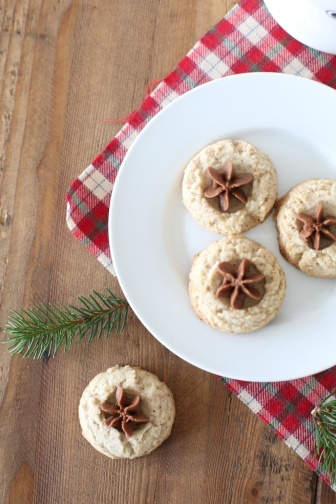What practical occasion could these cookies be prepared for? These cookies would be perfect for a family holiday gathering, a festive party with friends, or as a thoughtful homemade gift during the Christmas season. Their elegant and festive decoration makes them ideal for any occasion celebrating warmth, togetherness, and the holiday spirit. Imagine a playful interaction involving these cookies at a family holiday gathering. During the family holiday gathering, Uncle Tim, with a twinkle in his eye, announced a cookie decorating contest. Each family member would take a plain cookie and an assortment of toppings, including star anise, to create their own masterpiece. Amidst laughter and friendly competition, little Emma proudly presented her cookie, cheerfully declaring it 'the prettiest starry night.' The room filled with joy, as everyone admired each other's creativity, savoring the delicious cookies and the priceless memories they were creating together. 